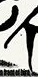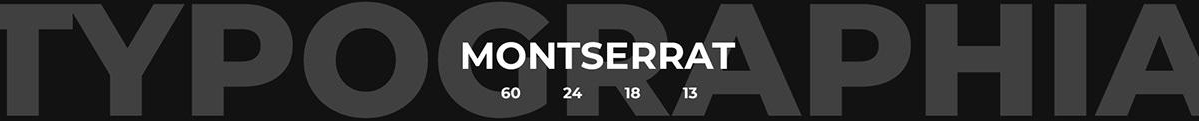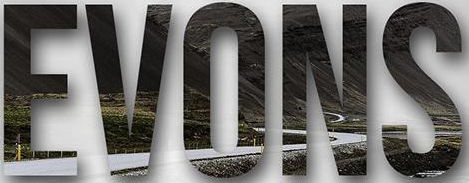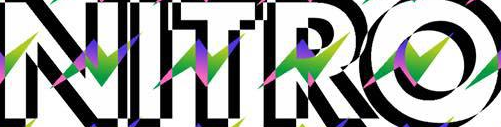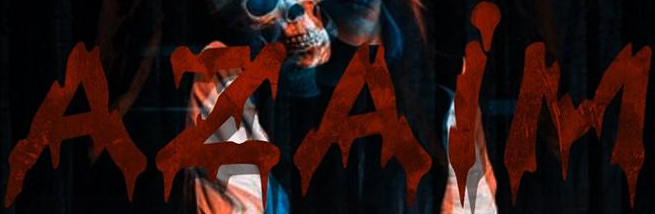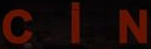Read the text content from these images in order, separated by a semicolon. #; TYPOGRAPHIA; EVONS; NITRO; AZAiM; CiN 